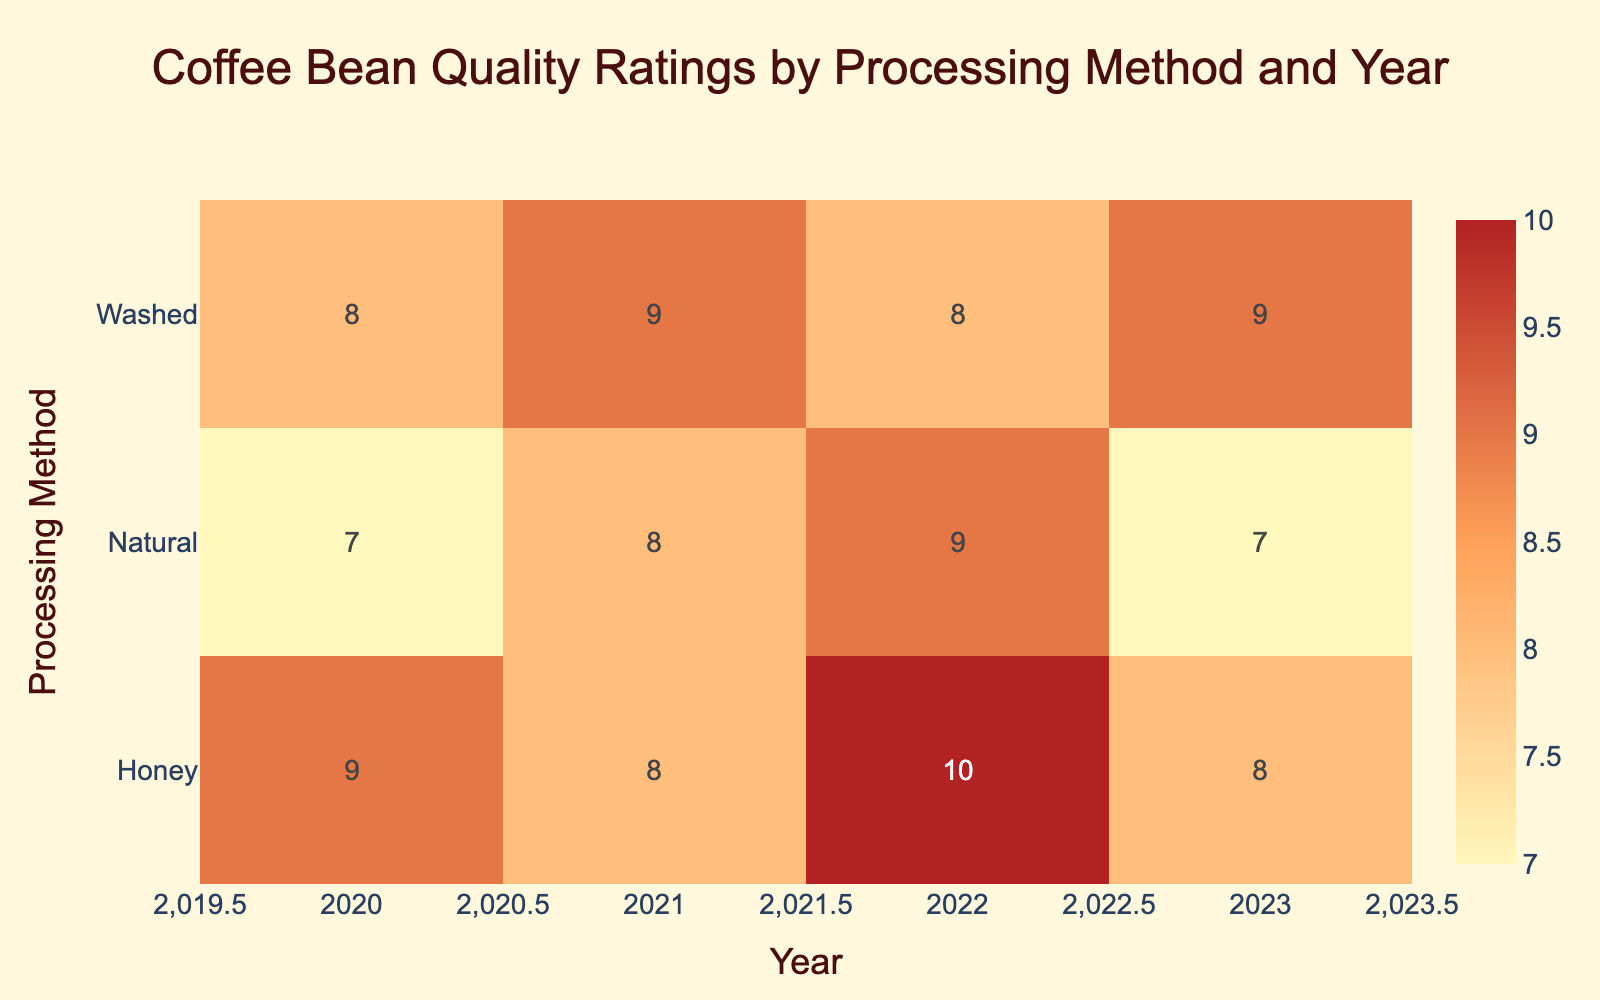What was the quality rating for Honey processing in 2022? The table shows that for the Honey processing method in 2022, the quality rating is represented in the cell corresponding to the year 2022 and the processing method Honey. Looking at that specific cell, the rating is 10.
Answer: 10 Which processing method had the highest average rating across all years? To determine which processing method has the highest average rating, we can look at the average values for each method. Adding up the ratings for each method (Washed: 8 + 9 + 8 + 9 = 34, Natural: 7 + 8 + 9 + 7 = 31, Honey: 9 + 8 + 10 + 8 = 35) and dividing by the number of years (4 for each method), we find that Honey has the highest average rating of 8.75.
Answer: Honey Did the quality rating for Natural processing improve from 2020 to 2023? By examining the quality ratings for Natural processing for the years 2020 (7), 2021 (8), 2022 (9), and 2023 (7), we can see the ratings increase from 7 to 9 in 2022, but then decrease to 7 in 2023. Thus, the rating did not improve, as it went back down in the last year.
Answer: No What is the difference in average ratings between Washed and Honey processing methods? First, we calculate the average ratings for both methods. For Washed, the average is (8 + 9 + 8 + 9) / 4 = 8.5. For Honey, the average is (9 + 8 + 10 + 8) / 4 = 8.75. The difference is 8.75 - 8.5 = 0.25, indicating Honey outperformed Washed by this margin.
Answer: 0.25 In how many years did the Honey processing method have a quality rating of 9 or more? Checking the ratings for Honey across the years, we find that it had a rating of 9 in 2020, 10 in 2022, and 8 in 2023. Thus, Honey had a rating of 9 or more in 2020 and 2022 only, which totals to 2 years.
Answer: 2 Which processing method had the lowest rating in 2021? By looking at the ratings for each processing method in 2021, we see Washed has a rating of 9, Natural has 8, and Honey has 8 as well. Therefore, since both Natural and Honey have the same lowest rating of 8, we conclude they are tied.
Answer: Natural and Honey 